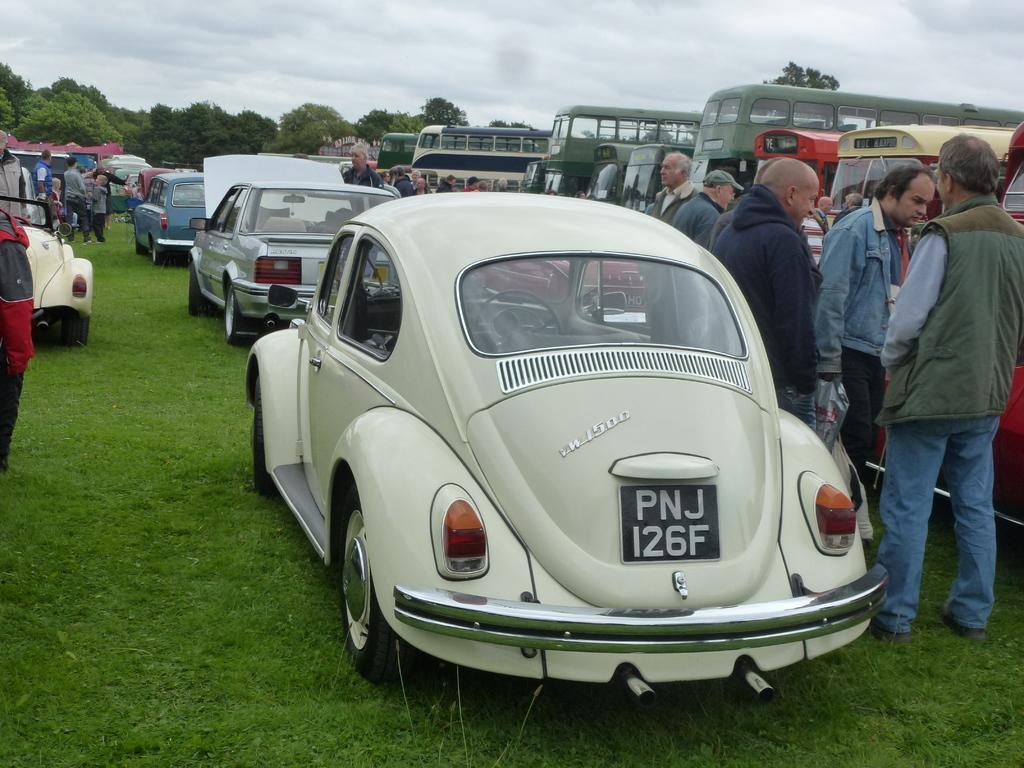Please provide a concise description of this image. In the center of the image there are many cars. There are many people standing. At the bottom of the image there is grass. In the background of the image there are trees. There are buses to the right side of the image. 